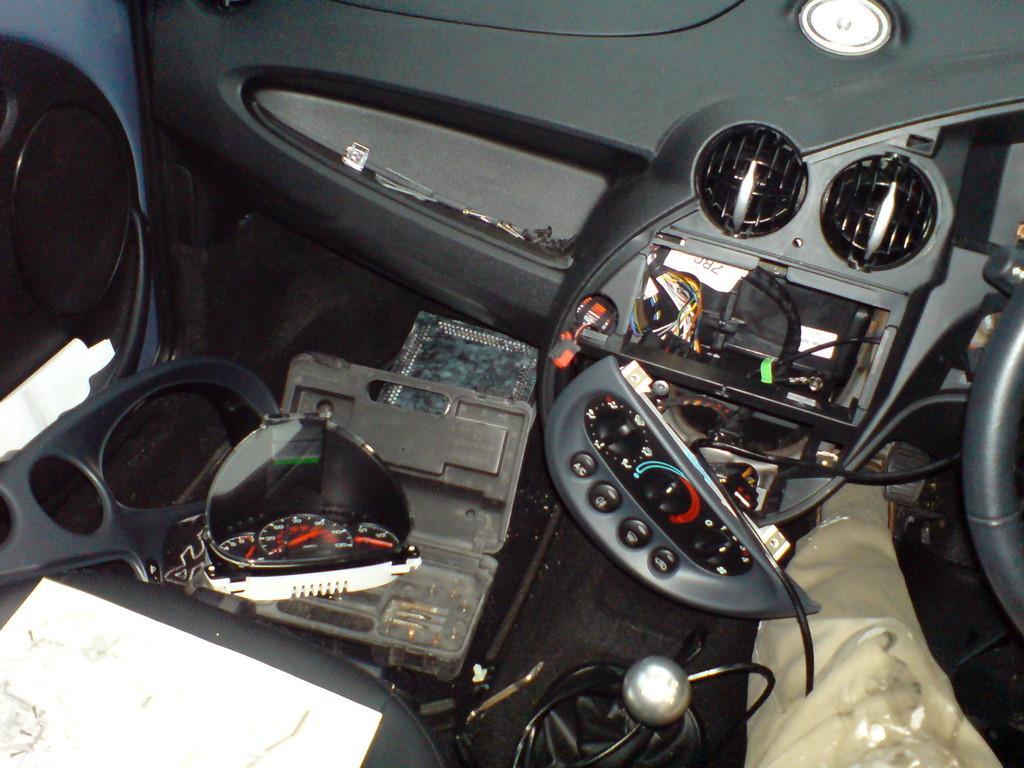In one or two sentences, can you explain what this image depicts? In this image it looks like inside of the car. And there are some parts of a car. And there are wires and box. And there is a paper. 